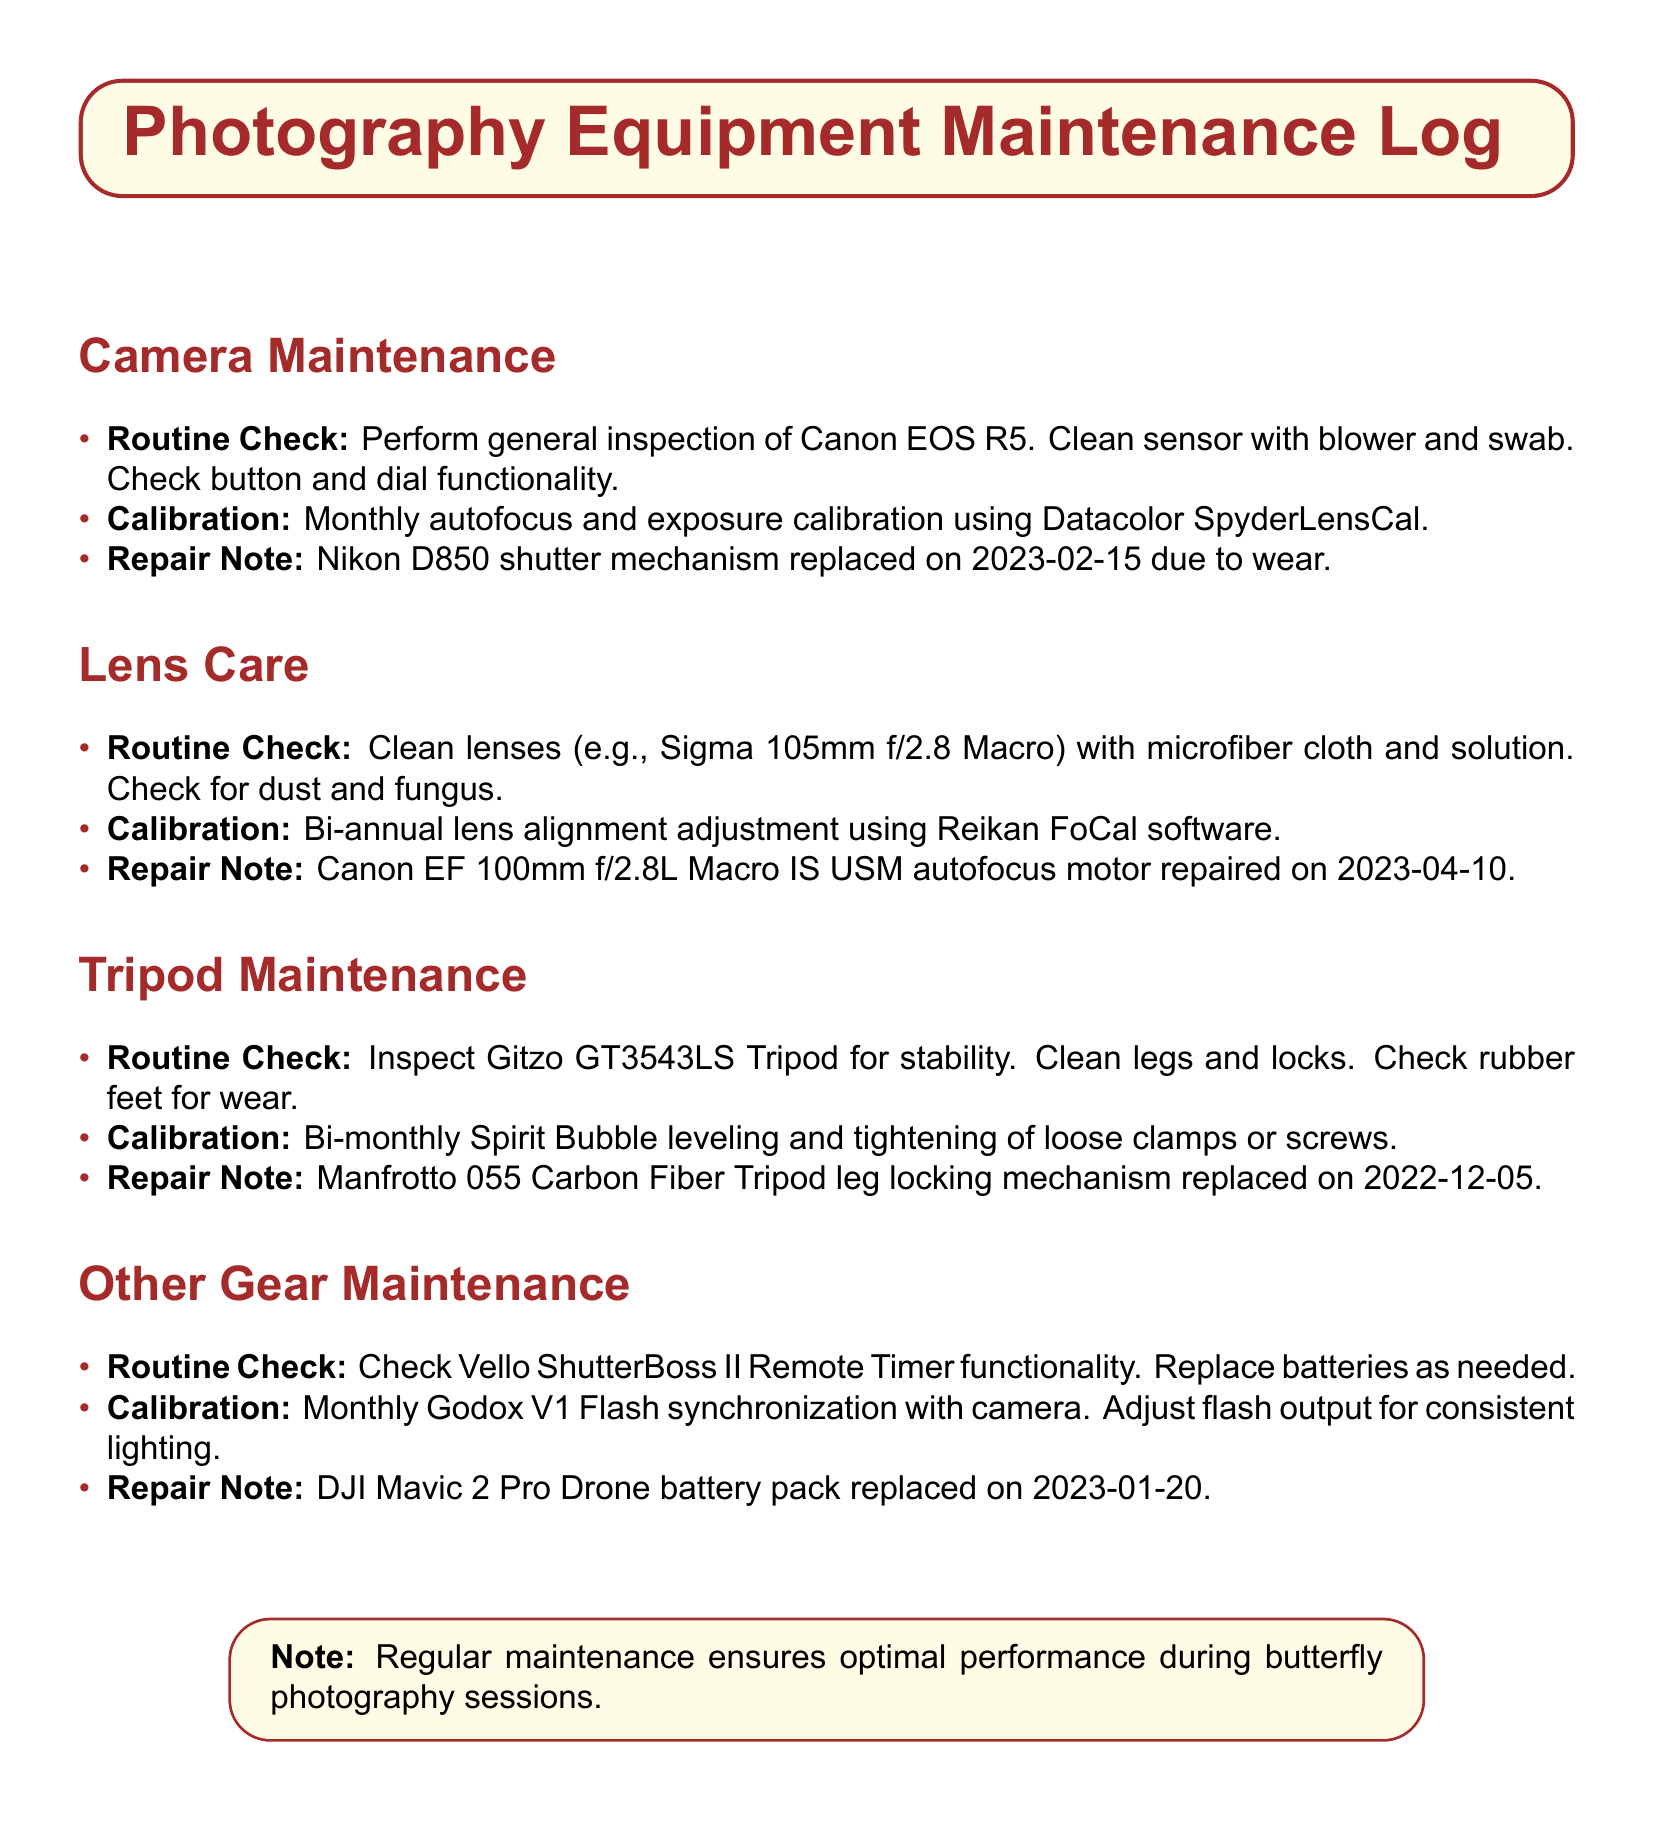What is the camera mentioned for routine check? The document lists the Canon EOS R5 for routine checks under Camera Maintenance.
Answer: Canon EOS R5 When was the Nikon D850 shutter mechanism replaced? The document specifies the date of repair for the Nikon D850 shutter mechanism as 2023-02-15.
Answer: 2023-02-15 What type of lenses undergo bi-annual calibration? The document references lens alignment adjustments for all lenses, specifically highlighting the cleaning of a Sigma 105mm f/2.8 Macro.
Answer: Sigma 105mm f/2.8 Macro How often is the tripod checked for stability? The document notes that the Gitzo GT3543LS Tripod is inspected for stability during routine checks.
Answer: Stability What equipment had a motor repaired on April 10, 2023? The Canon EF 100mm f/2.8L Macro IS USM had its autofocus motor repaired on this date.
Answer: Canon EF 100mm f/2.8L Macro IS USM What gear has its functionality checked monthly? The document mentions the Vello ShutterBoss II Remote Timer for routine functionality checks on a monthly basis.
Answer: Vello ShutterBoss II Remote Timer What color is used for the box around the title? The welcoming box for the title has the color defined as butterflyyellow.
Answer: butterflyyellow How frequently should the spirit bubble leveling be performed? The document states that spirit bubble leveling and tightening should happen bi-monthly.
Answer: Bi-monthly 